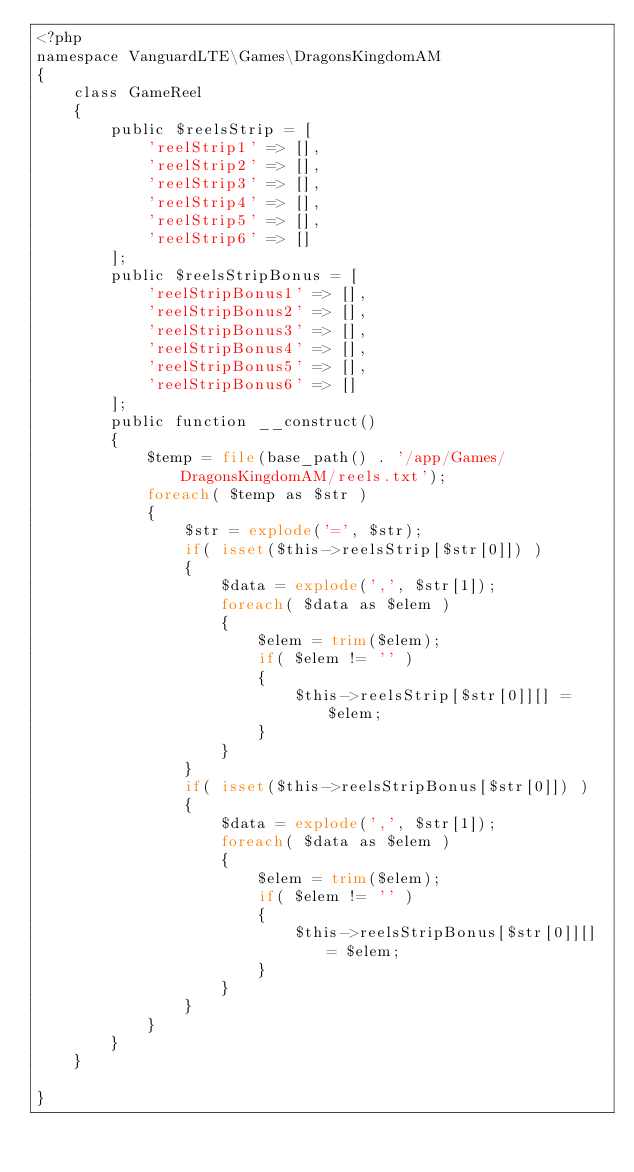Convert code to text. <code><loc_0><loc_0><loc_500><loc_500><_PHP_><?php 
namespace VanguardLTE\Games\DragonsKingdomAM
{
    class GameReel
    {
        public $reelsStrip = [
            'reelStrip1' => [], 
            'reelStrip2' => [], 
            'reelStrip3' => [], 
            'reelStrip4' => [], 
            'reelStrip5' => [], 
            'reelStrip6' => []
        ];
        public $reelsStripBonus = [
            'reelStripBonus1' => [], 
            'reelStripBonus2' => [], 
            'reelStripBonus3' => [], 
            'reelStripBonus4' => [], 
            'reelStripBonus5' => [], 
            'reelStripBonus6' => []
        ];
        public function __construct()
        {
            $temp = file(base_path() . '/app/Games/DragonsKingdomAM/reels.txt');
            foreach( $temp as $str ) 
            {
                $str = explode('=', $str);
                if( isset($this->reelsStrip[$str[0]]) ) 
                {
                    $data = explode(',', $str[1]);
                    foreach( $data as $elem ) 
                    {
                        $elem = trim($elem);
                        if( $elem != '' ) 
                        {
                            $this->reelsStrip[$str[0]][] = $elem;
                        }
                    }
                }
                if( isset($this->reelsStripBonus[$str[0]]) ) 
                {
                    $data = explode(',', $str[1]);
                    foreach( $data as $elem ) 
                    {
                        $elem = trim($elem);
                        if( $elem != '' ) 
                        {
                            $this->reelsStripBonus[$str[0]][] = $elem;
                        }
                    }
                }
            }
        }
    }

}
</code> 